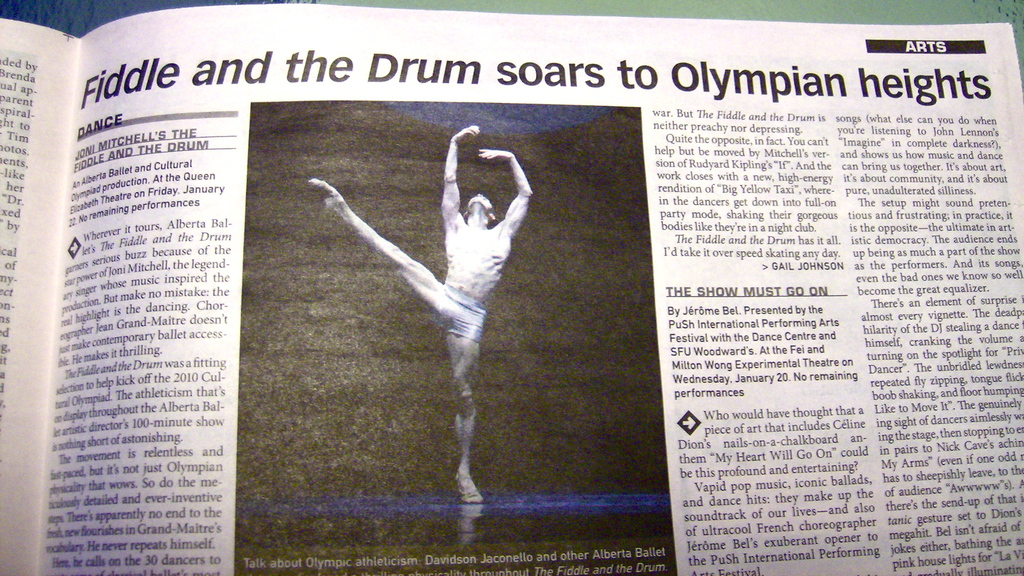How does the article describe the dancer's performance in the show? The article describes the dancer's performance as 'not just Olympian paced, but literally Olympian', signifying a high level of athleticism and artistic expression that resonates with the audience. 